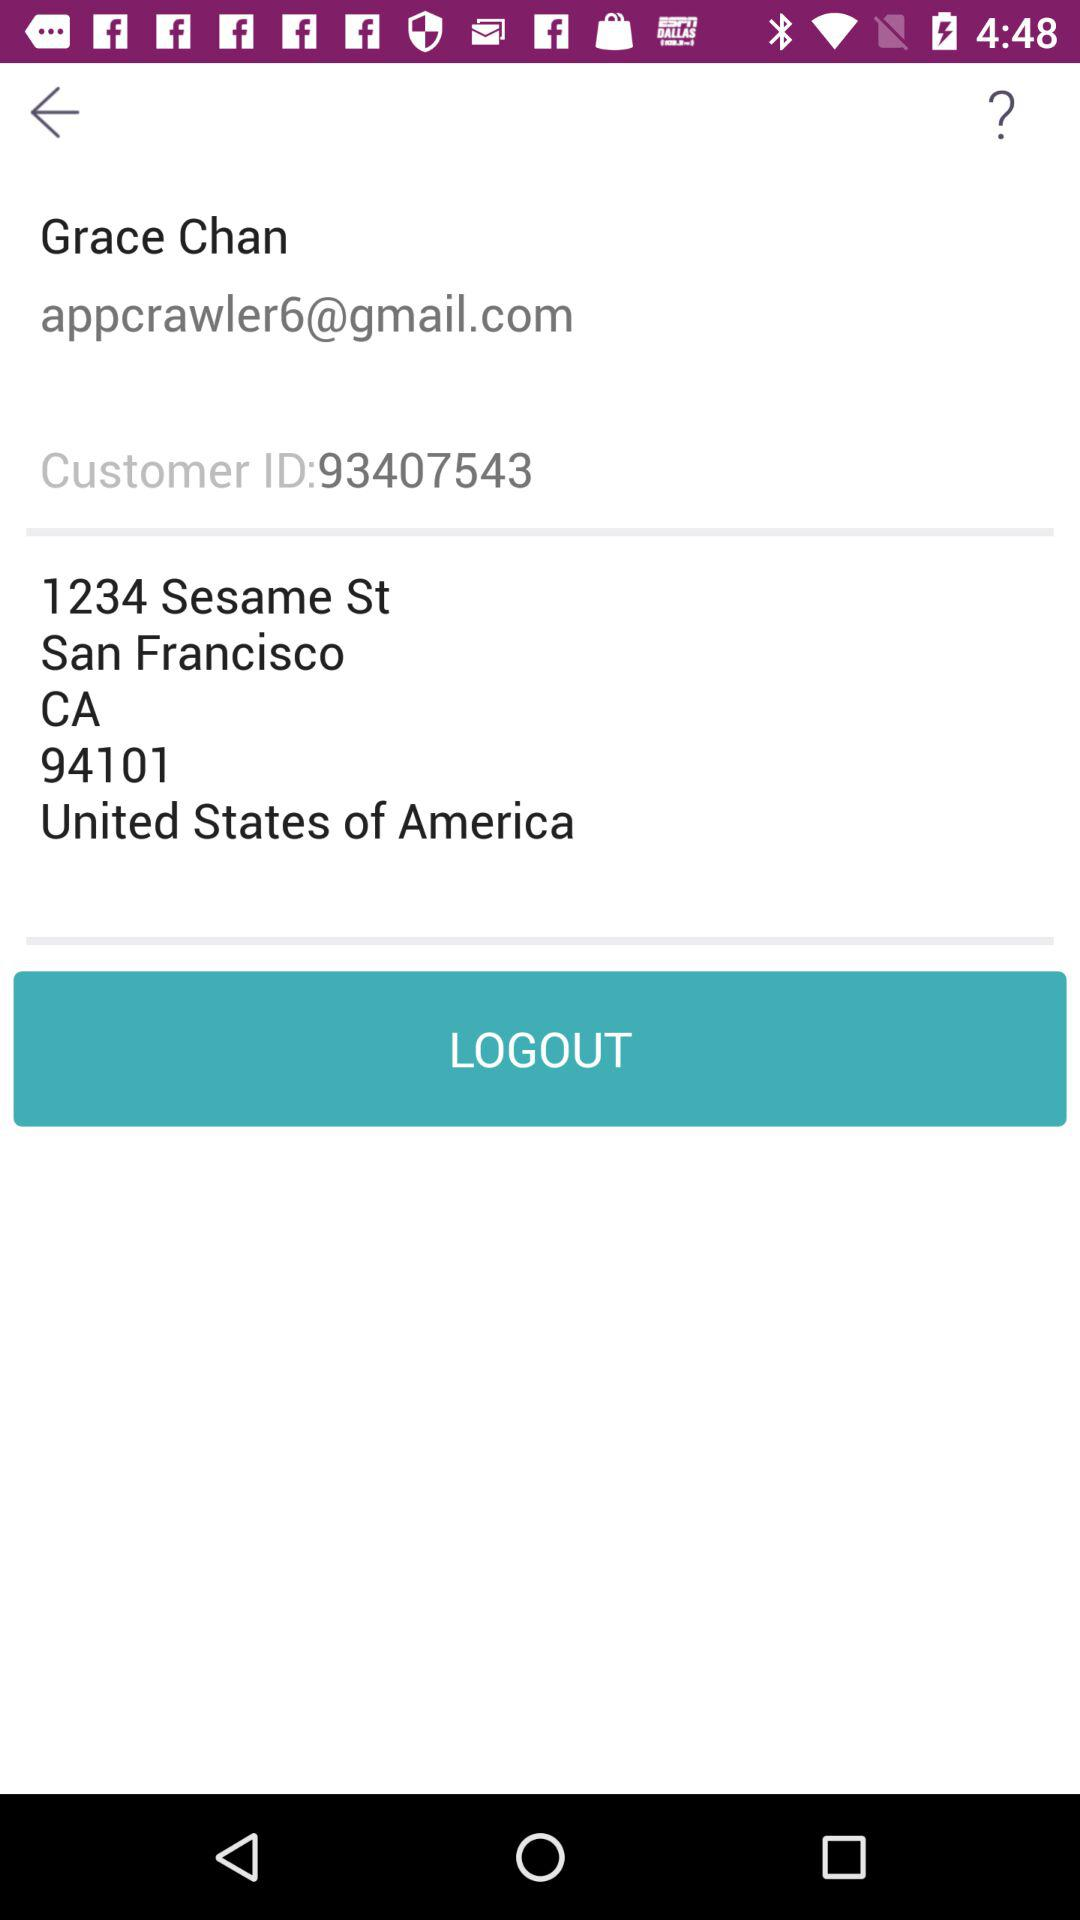What is the version of this application?
When the provided information is insufficient, respond with <no answer>. <no answer> 